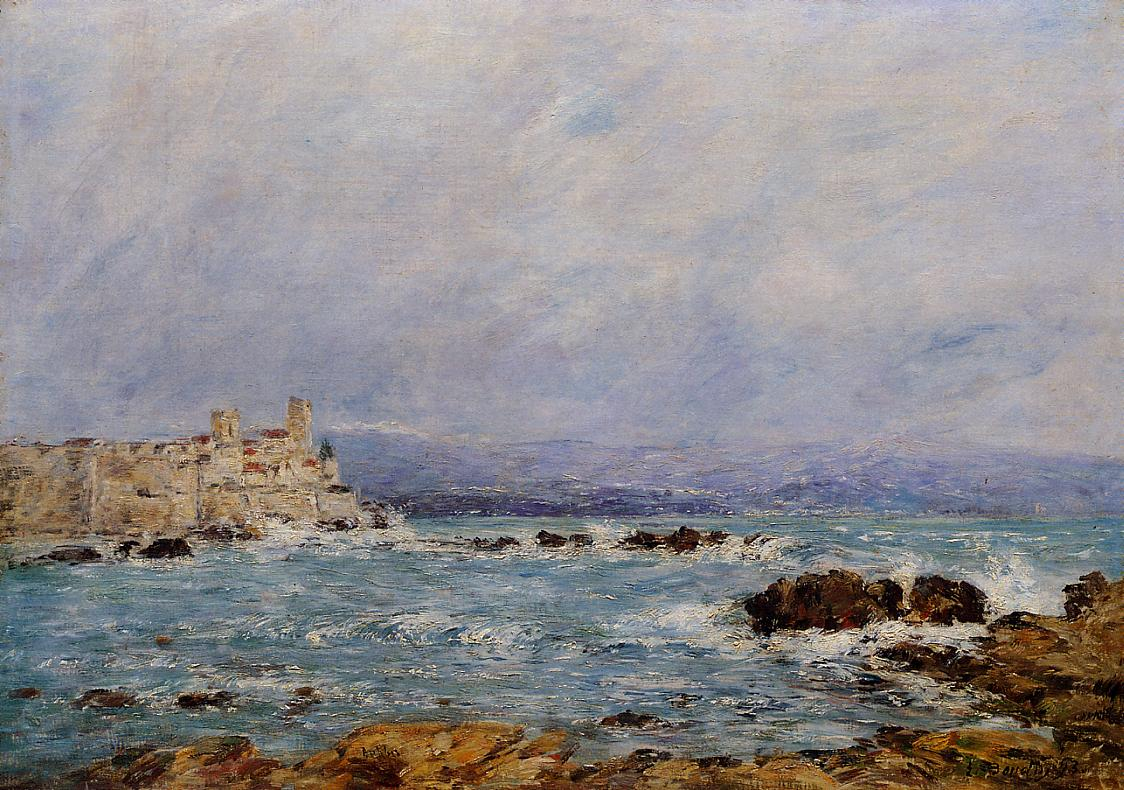If you could insert one modern element into this painting, what would it be and why? If I could insert one modern element into this painting, it would be a small, elegant sailboat gliding across the water. This addition would create an intriguing contrast between the timeless natural landscape and a recognizable contemporary feature, highlighting the enduring allure of the sea and the ongoing human fascination with exploring its vast expanse. The sailboat, with its sleek design and crisp, white sails catching the wind, would add a sense of direction and journey, inviting viewers to imagine their own adventures and connections to this serene coastal setting. 